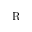<formula> <loc_0><loc_0><loc_500><loc_500>R</formula> 